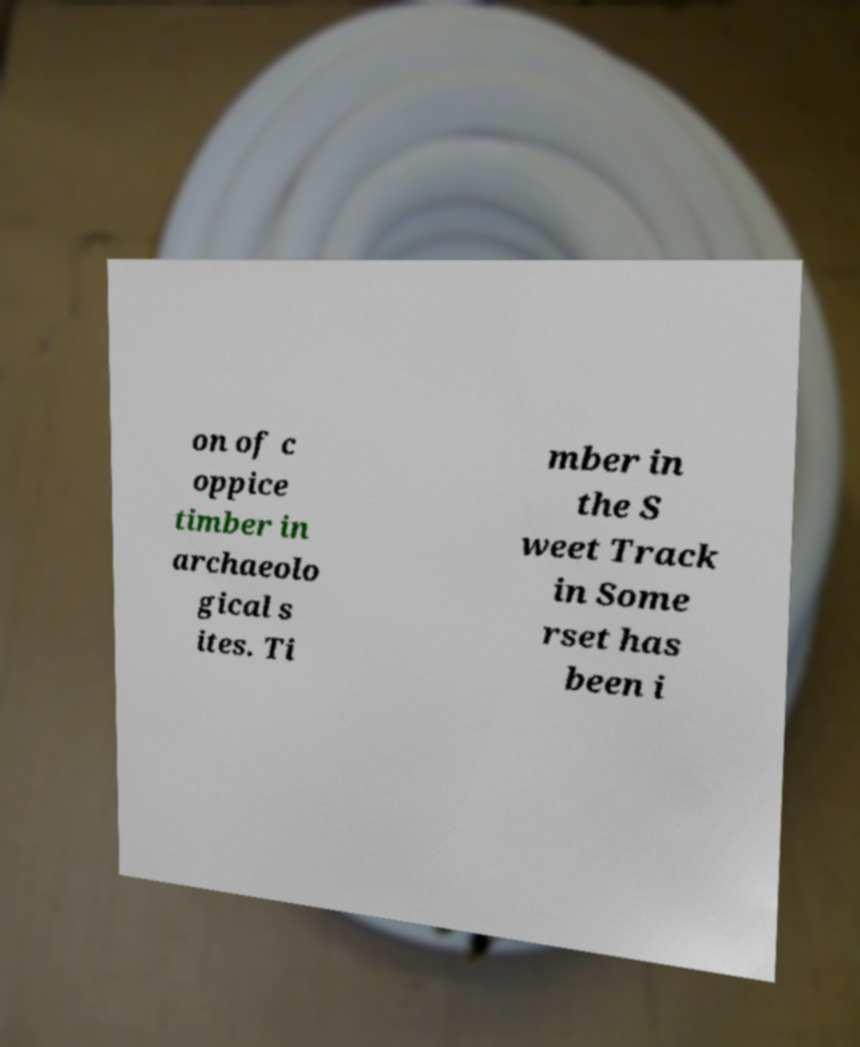I need the written content from this picture converted into text. Can you do that? on of c oppice timber in archaeolo gical s ites. Ti mber in the S weet Track in Some rset has been i 